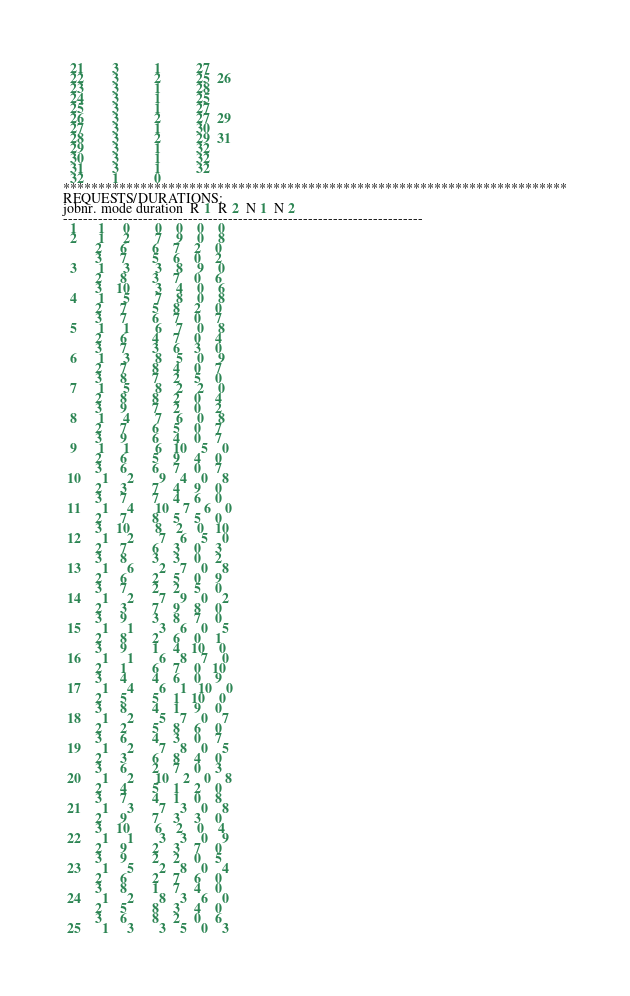<code> <loc_0><loc_0><loc_500><loc_500><_ObjectiveC_>  21        3          1          27
  22        3          2          25  26
  23        3          1          28
  24        3          1          25
  25        3          1          27
  26        3          2          27  29
  27        3          1          30
  28        3          2          29  31
  29        3          1          32
  30        3          1          32
  31        3          1          32
  32        1          0        
************************************************************************
REQUESTS/DURATIONS:
jobnr. mode duration  R 1  R 2  N 1  N 2
------------------------------------------------------------------------
  1      1     0       0    0    0    0
  2      1     2       7    9    0    8
         2     6       6    7    2    0
         3     7       5    6    0    2
  3      1     3       3    8    9    0
         2     8       3    7    0    6
         3    10       3    4    0    6
  4      1     5       7    8    0    8
         2     7       5    8    2    0
         3     7       6    7    0    7
  5      1     1       6    7    0    8
         2     6       4    7    0    4
         3     7       3    6    3    0
  6      1     3       8    5    0    9
         2     7       8    4    0    7
         3     8       7    2    5    0
  7      1     5       8    2    2    0
         2     8       8    2    0    4
         3     9       7    2    0    2
  8      1     4       7    6    0    8
         2     7       6    5    0    7
         3     9       6    4    0    7
  9      1     1       6   10    5    0
         2     6       5    9    4    0
         3     6       6    7    0    7
 10      1     2       9    4    0    8
         2     3       7    4    9    0
         3     7       7    4    6    0
 11      1     4      10    7    6    0
         2     7       8    5    5    0
         3    10       8    2    0   10
 12      1     2       7    6    5    0
         2     7       6    3    0    3
         3     8       3    3    0    2
 13      1     6       2    7    0    8
         2     6       2    5    0    9
         3     7       2    2    5    0
 14      1     2       7    9    0    2
         2     3       7    9    8    0
         3     9       3    8    7    0
 15      1     1       3    6    0    5
         2     8       2    6    0    1
         3     9       1    4   10    0
 16      1     1       6    8    7    0
         2     1       6    7    0   10
         3     4       4    6    0    9
 17      1     4       6    1   10    0
         2     5       5    1   10    0
         3     8       4    1    9    0
 18      1     2       5    7    0    7
         2     2       5    8    6    0
         3     6       4    3    0    7
 19      1     2       7    8    0    5
         2     3       6    8    4    0
         3     6       2    7    0    3
 20      1     2      10    2    0    8
         2     4       5    1    2    0
         3     7       4    1    0    8
 21      1     3       7    3    0    8
         2     9       7    3    3    0
         3    10       6    2    0    4
 22      1     1       3    3    0    9
         2     9       2    3    7    0
         3     9       2    2    0    5
 23      1     5       2    8    0    4
         2     6       2    7    6    0
         3     8       1    7    4    0
 24      1     2       8    3    6    0
         2     5       8    3    4    0
         3     6       8    2    0    6
 25      1     3       3    5    0    3</code> 